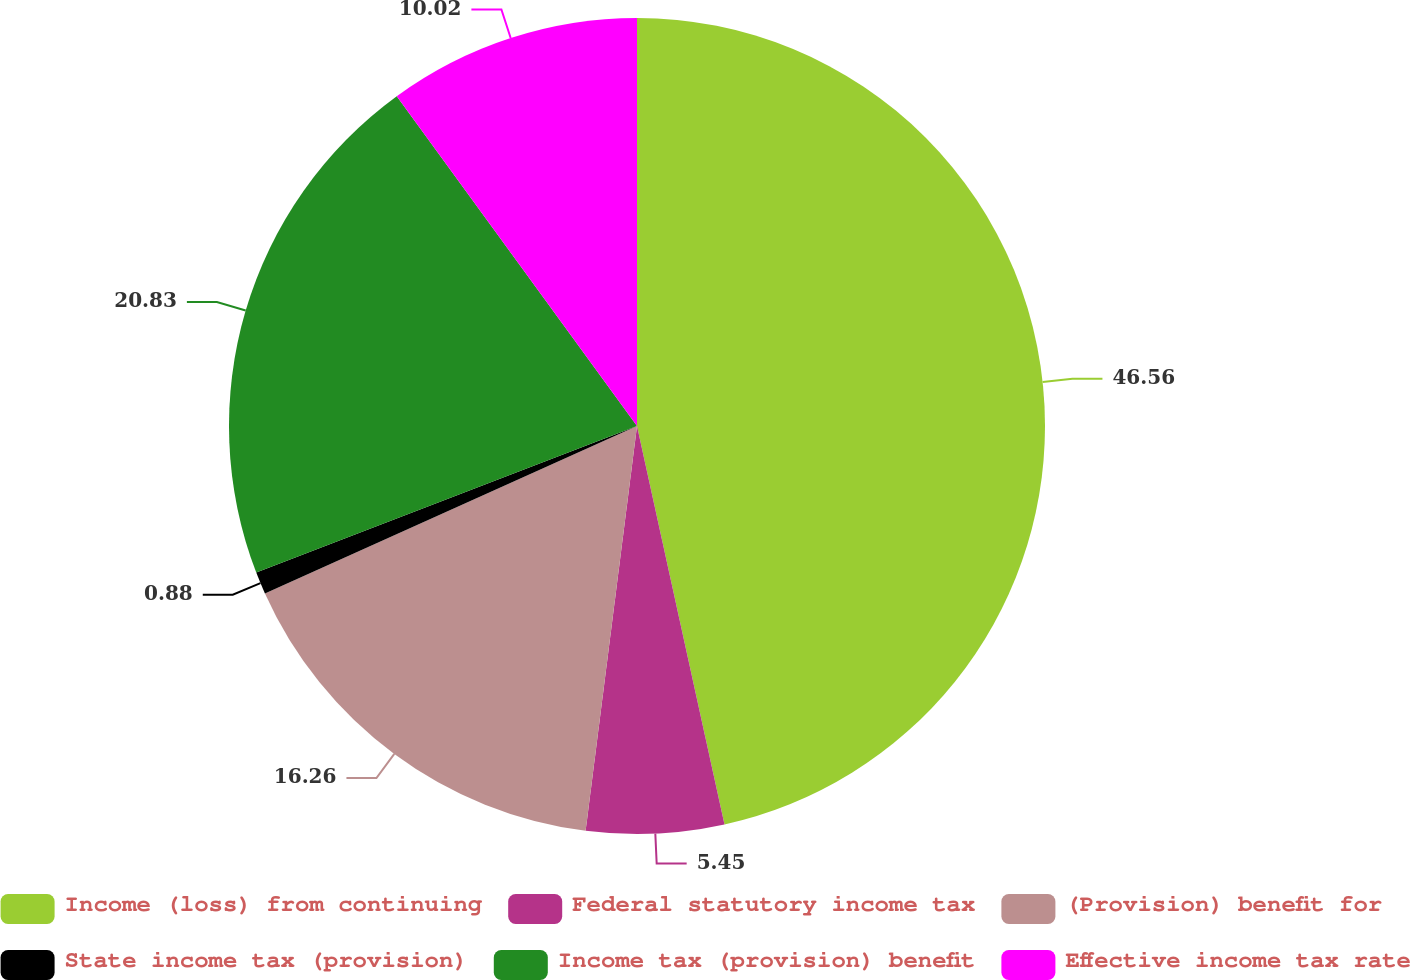Convert chart. <chart><loc_0><loc_0><loc_500><loc_500><pie_chart><fcel>Income (loss) from continuing<fcel>Federal statutory income tax<fcel>(Provision) benefit for<fcel>State income tax (provision)<fcel>Income tax (provision) benefit<fcel>Effective income tax rate<nl><fcel>46.56%<fcel>5.45%<fcel>16.26%<fcel>0.88%<fcel>20.83%<fcel>10.02%<nl></chart> 